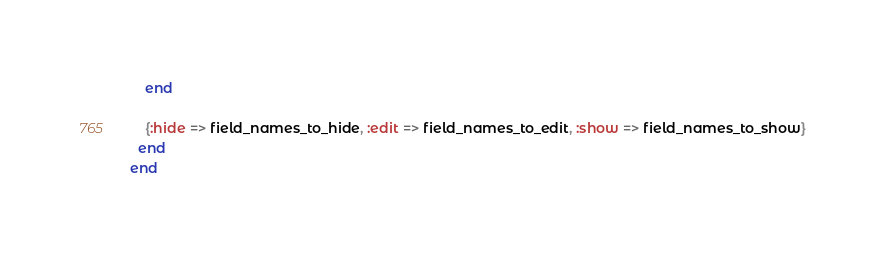<code> <loc_0><loc_0><loc_500><loc_500><_Ruby_>    end

    {:hide => field_names_to_hide, :edit => field_names_to_edit, :show => field_names_to_show}
  end
end
</code> 